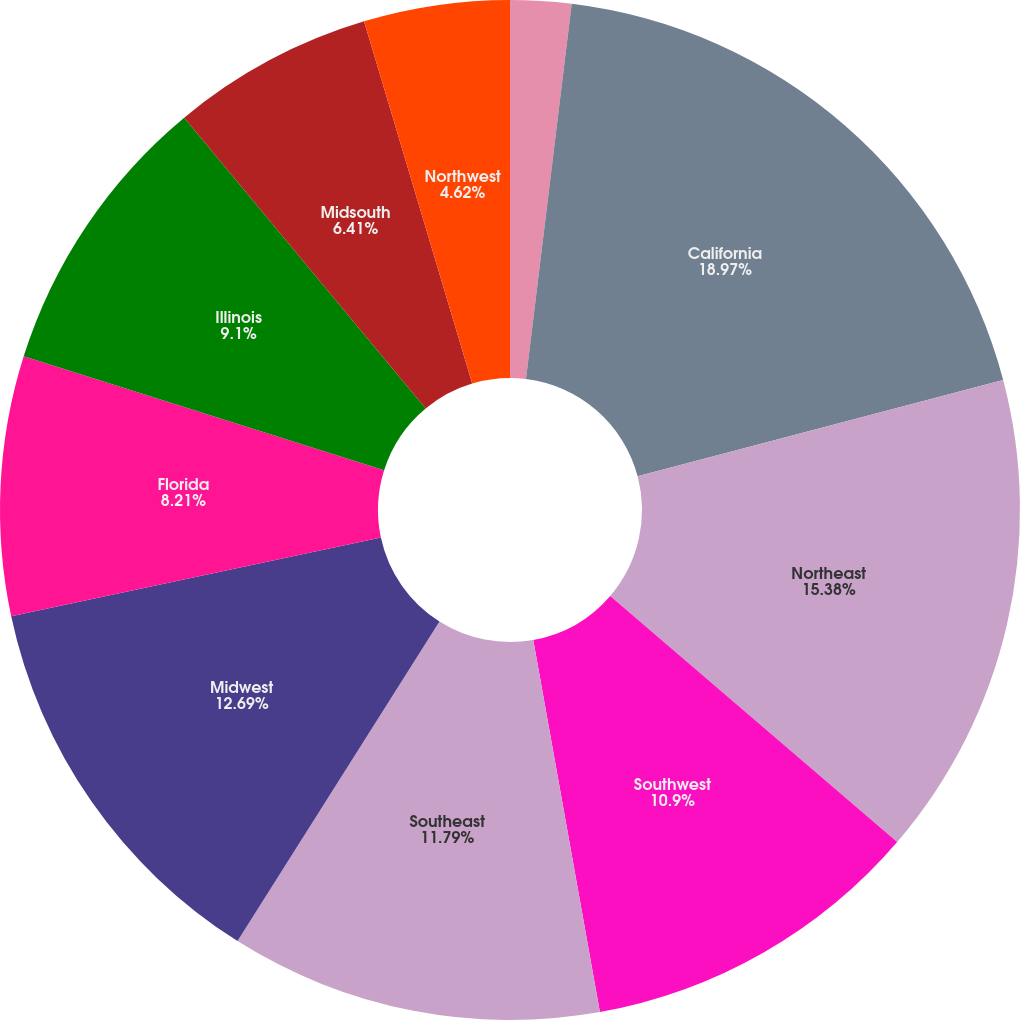Convert chart. <chart><loc_0><loc_0><loc_500><loc_500><pie_chart><fcel>(Dollars in millions)<fcel>California<fcel>Northeast<fcel>Southwest<fcel>Southeast<fcel>Midwest<fcel>Florida<fcel>Illinois<fcel>Midsouth<fcel>Northwest<nl><fcel>1.93%<fcel>18.97%<fcel>15.38%<fcel>10.9%<fcel>11.79%<fcel>12.69%<fcel>8.21%<fcel>9.1%<fcel>6.41%<fcel>4.62%<nl></chart> 